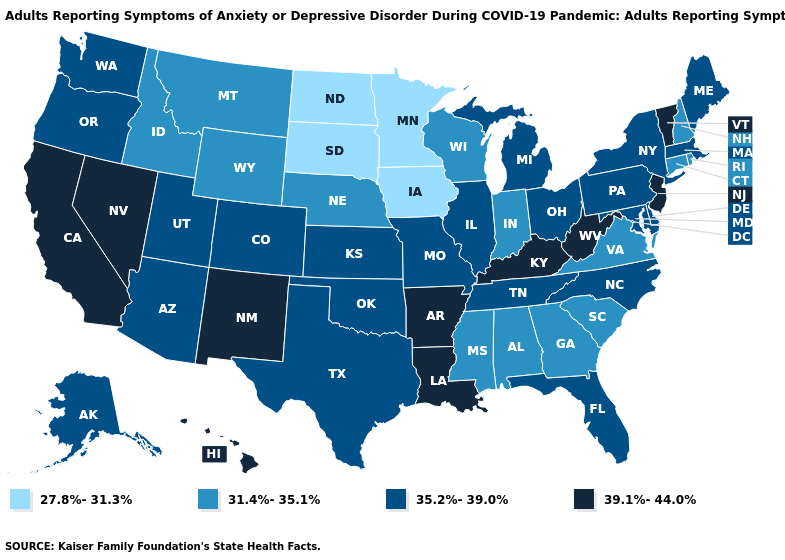Which states hav the highest value in the MidWest?
Keep it brief. Illinois, Kansas, Michigan, Missouri, Ohio. What is the highest value in the USA?
Write a very short answer. 39.1%-44.0%. What is the highest value in states that border Oklahoma?
Write a very short answer. 39.1%-44.0%. How many symbols are there in the legend?
Write a very short answer. 4. What is the lowest value in the USA?
Write a very short answer. 27.8%-31.3%. Which states have the lowest value in the Northeast?
Be succinct. Connecticut, New Hampshire, Rhode Island. What is the highest value in states that border Idaho?
Quick response, please. 39.1%-44.0%. What is the highest value in the MidWest ?
Answer briefly. 35.2%-39.0%. Name the states that have a value in the range 35.2%-39.0%?
Write a very short answer. Alaska, Arizona, Colorado, Delaware, Florida, Illinois, Kansas, Maine, Maryland, Massachusetts, Michigan, Missouri, New York, North Carolina, Ohio, Oklahoma, Oregon, Pennsylvania, Tennessee, Texas, Utah, Washington. Does Alaska have the lowest value in the USA?
Be succinct. No. How many symbols are there in the legend?
Quick response, please. 4. Does Texas have the same value as Kansas?
Write a very short answer. Yes. How many symbols are there in the legend?
Answer briefly. 4. What is the value of Maryland?
Keep it brief. 35.2%-39.0%. What is the highest value in states that border Maine?
Keep it brief. 31.4%-35.1%. 